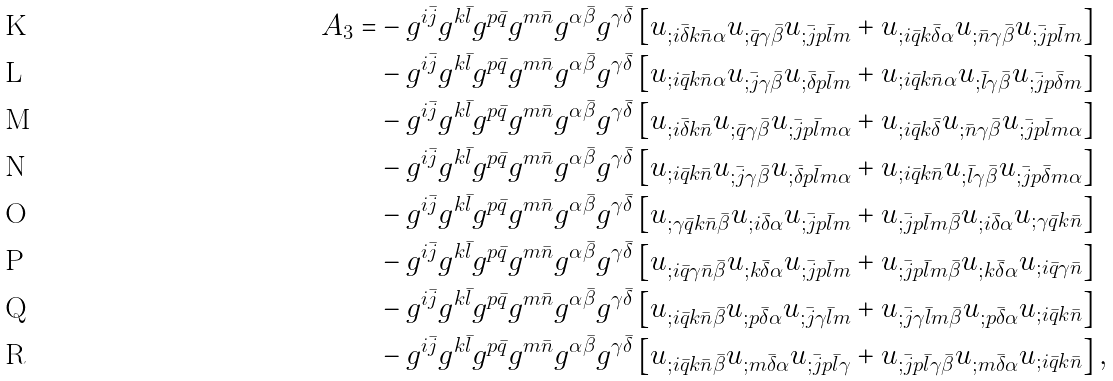<formula> <loc_0><loc_0><loc_500><loc_500>A _ { 3 } = & - g ^ { i \bar { j } } g ^ { k \bar { l } } g ^ { p \bar { q } } g ^ { m \bar { n } } g ^ { \alpha \bar { \beta } } g ^ { \gamma \bar { \delta } } \left [ u _ { ; i \bar { \delta } k \bar { n } \alpha } u _ { ; \bar { q } \gamma \bar { \beta } } u _ { ; \bar { j } p \bar { l } m } + u _ { ; i \bar { q } k \bar { \delta } \alpha } u _ { ; \bar { n } \gamma \bar { \beta } } u _ { ; \bar { j } p \bar { l } m } \right ] \\ & - g ^ { i \bar { j } } g ^ { k \bar { l } } g ^ { p \bar { q } } g ^ { m \bar { n } } g ^ { \alpha \bar { \beta } } g ^ { \gamma \bar { \delta } } \left [ u _ { ; i \bar { q } k \bar { n } \alpha } u _ { ; \bar { j } \gamma \bar { \beta } } u _ { ; \bar { \delta } p \bar { l } m } + u _ { ; i \bar { q } k \bar { n } \alpha } u _ { ; \bar { l } \gamma \bar { \beta } } u _ { ; \bar { j } p \bar { \delta } m } \right ] \\ & - g ^ { i \bar { j } } g ^ { k \bar { l } } g ^ { p \bar { q } } g ^ { m \bar { n } } g ^ { \alpha \bar { \beta } } g ^ { \gamma \bar { \delta } } \left [ u _ { ; i \bar { \delta } k \bar { n } } u _ { ; \bar { q } \gamma \bar { \beta } } u _ { ; \bar { j } p \bar { l } m \alpha } + u _ { ; i \bar { q } k \bar { \delta } } u _ { ; \bar { n } \gamma \bar { \beta } } u _ { ; \bar { j } p \bar { l } m \alpha } \right ] \\ & - g ^ { i \bar { j } } g ^ { k \bar { l } } g ^ { p \bar { q } } g ^ { m \bar { n } } g ^ { \alpha \bar { \beta } } g ^ { \gamma \bar { \delta } } \left [ u _ { ; i \bar { q } k \bar { n } } u _ { ; \bar { j } \gamma \bar { \beta } } u _ { ; \bar { \delta } p \bar { l } m \alpha } + u _ { ; i \bar { q } k \bar { n } } u _ { ; \bar { l } \gamma \bar { \beta } } u _ { ; \bar { j } p \bar { \delta } m \alpha } \right ] \\ & - g ^ { i \bar { j } } g ^ { k \bar { l } } g ^ { p \bar { q } } g ^ { m \bar { n } } g ^ { \alpha \bar { \beta } } g ^ { \gamma \bar { \delta } } \left [ u _ { ; \gamma \bar { q } k \bar { n } \bar { \beta } } u _ { ; i \bar { \delta } \alpha } u _ { ; \bar { j } p \bar { l } m } + u _ { ; \bar { j } p \bar { l } m \bar { \beta } } u _ { ; i \bar { \delta } \alpha } u _ { ; \gamma \bar { q } k \bar { n } } \right ] \\ & - g ^ { i \bar { j } } g ^ { k \bar { l } } g ^ { p \bar { q } } g ^ { m \bar { n } } g ^ { \alpha \bar { \beta } } g ^ { \gamma \bar { \delta } } \left [ u _ { ; i \bar { q } \gamma \bar { n } \bar { \beta } } u _ { ; k \bar { \delta } \alpha } u _ { ; \bar { j } p \bar { l } m } + u _ { ; \bar { j } p \bar { l } m \bar { \beta } } u _ { ; k \bar { \delta } \alpha } u _ { ; i \bar { q } \gamma \bar { n } } \right ] \\ & - g ^ { i \bar { j } } g ^ { k \bar { l } } g ^ { p \bar { q } } g ^ { m \bar { n } } g ^ { \alpha \bar { \beta } } g ^ { \gamma \bar { \delta } } \left [ u _ { ; i \bar { q } k \bar { n } \bar { \beta } } u _ { ; p \bar { \delta } \alpha } u _ { ; \bar { j } \gamma \bar { l } m } + u _ { ; \bar { j } \gamma \bar { l } m \bar { \beta } } u _ { ; p \bar { \delta } \alpha } u _ { ; i \bar { q } k \bar { n } } \right ] \\ & - g ^ { i \bar { j } } g ^ { k \bar { l } } g ^ { p \bar { q } } g ^ { m \bar { n } } g ^ { \alpha \bar { \beta } } g ^ { \gamma \bar { \delta } } \left [ u _ { ; i \bar { q } k \bar { n } \bar { \beta } } u _ { ; m \bar { \delta } \alpha } u _ { ; \bar { j } p \bar { l } \gamma } + u _ { ; \bar { j } p \bar { l } \gamma \bar { \beta } } u _ { ; m \bar { \delta } \alpha } u _ { ; i \bar { q } k \bar { n } } \right ] ,</formula> 